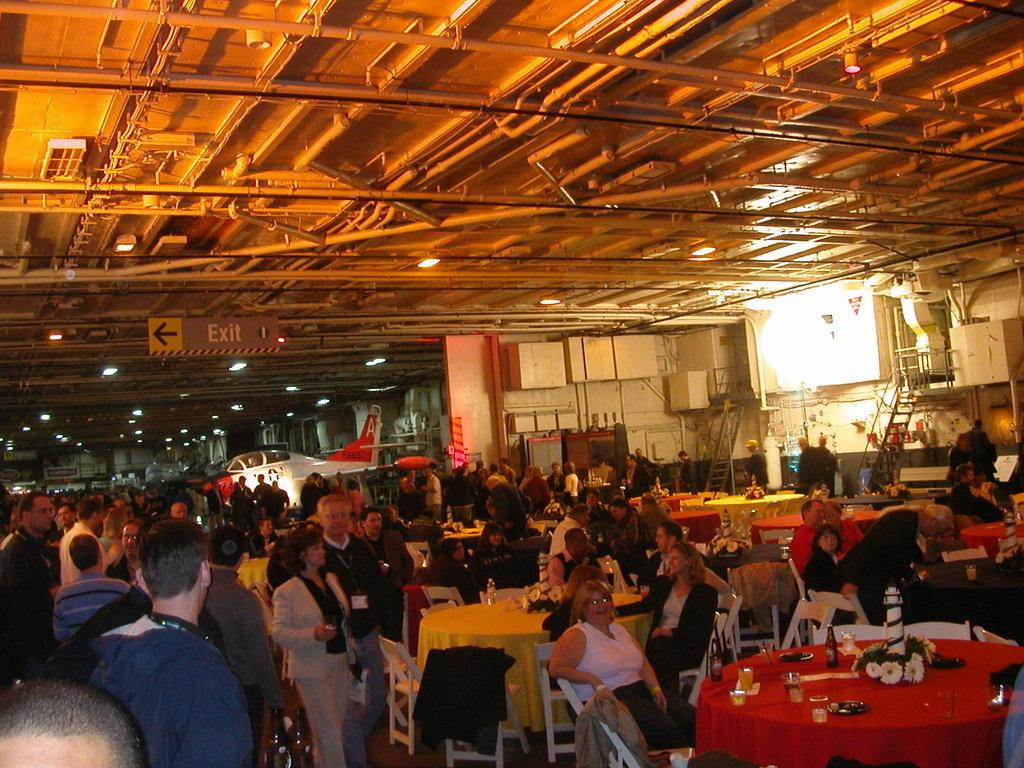How many people are in the image? There is a group of people in the image, but the exact number is not specified. What are the people in the image doing? The people are standing in the image. What objects can be seen in the background of the image? There is a table, a chair, and an airplane in the background of the image. What type of flower is being discovered by the people in the image? There is no flower present in the image, nor is there any indication of a discovery being made. 